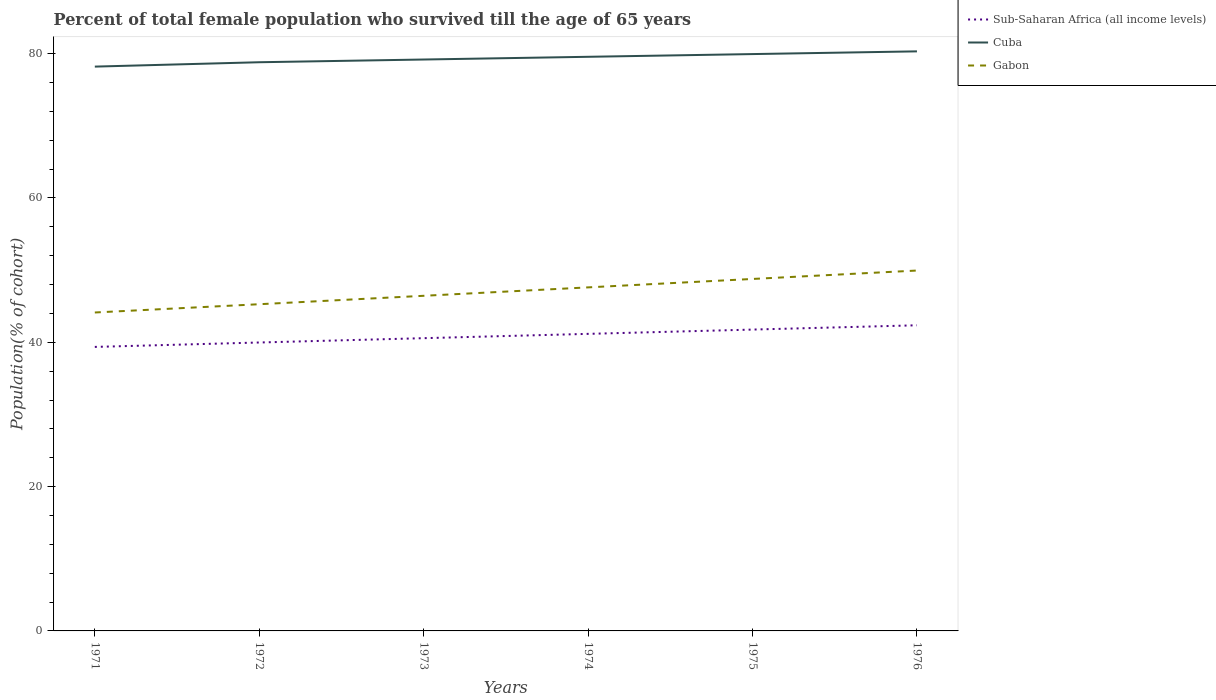How many different coloured lines are there?
Your response must be concise. 3. Does the line corresponding to Gabon intersect with the line corresponding to Cuba?
Give a very brief answer. No. Is the number of lines equal to the number of legend labels?
Provide a succinct answer. Yes. Across all years, what is the maximum percentage of total female population who survived till the age of 65 years in Sub-Saharan Africa (all income levels)?
Keep it short and to the point. 39.36. What is the total percentage of total female population who survived till the age of 65 years in Cuba in the graph?
Your answer should be very brief. -1.51. What is the difference between the highest and the second highest percentage of total female population who survived till the age of 65 years in Gabon?
Make the answer very short. 5.81. What is the difference between the highest and the lowest percentage of total female population who survived till the age of 65 years in Gabon?
Your answer should be compact. 3. How many lines are there?
Your response must be concise. 3. How many years are there in the graph?
Provide a short and direct response. 6. Are the values on the major ticks of Y-axis written in scientific E-notation?
Ensure brevity in your answer.  No. Does the graph contain grids?
Your response must be concise. No. Where does the legend appear in the graph?
Your answer should be very brief. Top right. How many legend labels are there?
Offer a terse response. 3. What is the title of the graph?
Keep it short and to the point. Percent of total female population who survived till the age of 65 years. Does "New Caledonia" appear as one of the legend labels in the graph?
Give a very brief answer. No. What is the label or title of the X-axis?
Provide a short and direct response. Years. What is the label or title of the Y-axis?
Keep it short and to the point. Population(% of cohort). What is the Population(% of cohort) of Sub-Saharan Africa (all income levels) in 1971?
Give a very brief answer. 39.36. What is the Population(% of cohort) in Cuba in 1971?
Make the answer very short. 78.2. What is the Population(% of cohort) of Gabon in 1971?
Offer a very short reply. 44.13. What is the Population(% of cohort) of Sub-Saharan Africa (all income levels) in 1972?
Your answer should be very brief. 39.97. What is the Population(% of cohort) in Cuba in 1972?
Offer a very short reply. 78.81. What is the Population(% of cohort) of Gabon in 1972?
Your response must be concise. 45.27. What is the Population(% of cohort) of Sub-Saharan Africa (all income levels) in 1973?
Keep it short and to the point. 40.57. What is the Population(% of cohort) in Cuba in 1973?
Make the answer very short. 79.18. What is the Population(% of cohort) of Gabon in 1973?
Offer a very short reply. 46.44. What is the Population(% of cohort) in Sub-Saharan Africa (all income levels) in 1974?
Your answer should be compact. 41.16. What is the Population(% of cohort) of Cuba in 1974?
Your response must be concise. 79.56. What is the Population(% of cohort) in Gabon in 1974?
Provide a short and direct response. 47.61. What is the Population(% of cohort) of Sub-Saharan Africa (all income levels) in 1975?
Offer a terse response. 41.76. What is the Population(% of cohort) in Cuba in 1975?
Your response must be concise. 79.94. What is the Population(% of cohort) of Gabon in 1975?
Your response must be concise. 48.77. What is the Population(% of cohort) of Sub-Saharan Africa (all income levels) in 1976?
Give a very brief answer. 42.35. What is the Population(% of cohort) of Cuba in 1976?
Make the answer very short. 80.31. What is the Population(% of cohort) of Gabon in 1976?
Offer a terse response. 49.94. Across all years, what is the maximum Population(% of cohort) in Sub-Saharan Africa (all income levels)?
Ensure brevity in your answer.  42.35. Across all years, what is the maximum Population(% of cohort) in Cuba?
Your answer should be compact. 80.31. Across all years, what is the maximum Population(% of cohort) in Gabon?
Provide a succinct answer. 49.94. Across all years, what is the minimum Population(% of cohort) of Sub-Saharan Africa (all income levels)?
Give a very brief answer. 39.36. Across all years, what is the minimum Population(% of cohort) of Cuba?
Ensure brevity in your answer.  78.2. Across all years, what is the minimum Population(% of cohort) in Gabon?
Offer a terse response. 44.13. What is the total Population(% of cohort) of Sub-Saharan Africa (all income levels) in the graph?
Your response must be concise. 245.17. What is the total Population(% of cohort) of Cuba in the graph?
Ensure brevity in your answer.  476. What is the total Population(% of cohort) of Gabon in the graph?
Make the answer very short. 282.16. What is the difference between the Population(% of cohort) of Sub-Saharan Africa (all income levels) in 1971 and that in 1972?
Your answer should be very brief. -0.61. What is the difference between the Population(% of cohort) of Cuba in 1971 and that in 1972?
Provide a short and direct response. -0.61. What is the difference between the Population(% of cohort) in Gabon in 1971 and that in 1972?
Offer a very short reply. -1.15. What is the difference between the Population(% of cohort) in Sub-Saharan Africa (all income levels) in 1971 and that in 1973?
Your response must be concise. -1.21. What is the difference between the Population(% of cohort) of Cuba in 1971 and that in 1973?
Your answer should be compact. -0.98. What is the difference between the Population(% of cohort) in Gabon in 1971 and that in 1973?
Your answer should be compact. -2.31. What is the difference between the Population(% of cohort) in Sub-Saharan Africa (all income levels) in 1971 and that in 1974?
Your answer should be compact. -1.81. What is the difference between the Population(% of cohort) of Cuba in 1971 and that in 1974?
Your response must be concise. -1.36. What is the difference between the Population(% of cohort) of Gabon in 1971 and that in 1974?
Make the answer very short. -3.48. What is the difference between the Population(% of cohort) of Sub-Saharan Africa (all income levels) in 1971 and that in 1975?
Provide a short and direct response. -2.4. What is the difference between the Population(% of cohort) of Cuba in 1971 and that in 1975?
Keep it short and to the point. -1.74. What is the difference between the Population(% of cohort) in Gabon in 1971 and that in 1975?
Keep it short and to the point. -4.65. What is the difference between the Population(% of cohort) in Sub-Saharan Africa (all income levels) in 1971 and that in 1976?
Offer a terse response. -3. What is the difference between the Population(% of cohort) of Cuba in 1971 and that in 1976?
Provide a succinct answer. -2.11. What is the difference between the Population(% of cohort) of Gabon in 1971 and that in 1976?
Keep it short and to the point. -5.81. What is the difference between the Population(% of cohort) of Sub-Saharan Africa (all income levels) in 1972 and that in 1973?
Provide a short and direct response. -0.6. What is the difference between the Population(% of cohort) in Cuba in 1972 and that in 1973?
Your answer should be very brief. -0.38. What is the difference between the Population(% of cohort) in Gabon in 1972 and that in 1973?
Your response must be concise. -1.17. What is the difference between the Population(% of cohort) in Sub-Saharan Africa (all income levels) in 1972 and that in 1974?
Your answer should be compact. -1.2. What is the difference between the Population(% of cohort) of Cuba in 1972 and that in 1974?
Make the answer very short. -0.75. What is the difference between the Population(% of cohort) in Gabon in 1972 and that in 1974?
Make the answer very short. -2.33. What is the difference between the Population(% of cohort) in Sub-Saharan Africa (all income levels) in 1972 and that in 1975?
Your answer should be compact. -1.79. What is the difference between the Population(% of cohort) in Cuba in 1972 and that in 1975?
Offer a very short reply. -1.13. What is the difference between the Population(% of cohort) in Gabon in 1972 and that in 1975?
Keep it short and to the point. -3.5. What is the difference between the Population(% of cohort) in Sub-Saharan Africa (all income levels) in 1972 and that in 1976?
Provide a short and direct response. -2.39. What is the difference between the Population(% of cohort) of Cuba in 1972 and that in 1976?
Make the answer very short. -1.51. What is the difference between the Population(% of cohort) of Gabon in 1972 and that in 1976?
Your answer should be compact. -4.67. What is the difference between the Population(% of cohort) of Sub-Saharan Africa (all income levels) in 1973 and that in 1974?
Ensure brevity in your answer.  -0.6. What is the difference between the Population(% of cohort) in Cuba in 1973 and that in 1974?
Offer a very short reply. -0.38. What is the difference between the Population(% of cohort) in Gabon in 1973 and that in 1974?
Provide a short and direct response. -1.17. What is the difference between the Population(% of cohort) of Sub-Saharan Africa (all income levels) in 1973 and that in 1975?
Your response must be concise. -1.19. What is the difference between the Population(% of cohort) of Cuba in 1973 and that in 1975?
Your answer should be compact. -0.75. What is the difference between the Population(% of cohort) of Gabon in 1973 and that in 1975?
Your answer should be very brief. -2.33. What is the difference between the Population(% of cohort) in Sub-Saharan Africa (all income levels) in 1973 and that in 1976?
Provide a short and direct response. -1.79. What is the difference between the Population(% of cohort) in Cuba in 1973 and that in 1976?
Your answer should be compact. -1.13. What is the difference between the Population(% of cohort) of Gabon in 1973 and that in 1976?
Provide a succinct answer. -3.5. What is the difference between the Population(% of cohort) in Sub-Saharan Africa (all income levels) in 1974 and that in 1975?
Give a very brief answer. -0.59. What is the difference between the Population(% of cohort) in Cuba in 1974 and that in 1975?
Offer a very short reply. -0.38. What is the difference between the Population(% of cohort) in Gabon in 1974 and that in 1975?
Your answer should be compact. -1.17. What is the difference between the Population(% of cohort) in Sub-Saharan Africa (all income levels) in 1974 and that in 1976?
Offer a terse response. -1.19. What is the difference between the Population(% of cohort) in Cuba in 1974 and that in 1976?
Your answer should be very brief. -0.75. What is the difference between the Population(% of cohort) in Gabon in 1974 and that in 1976?
Provide a succinct answer. -2.33. What is the difference between the Population(% of cohort) in Sub-Saharan Africa (all income levels) in 1975 and that in 1976?
Your answer should be very brief. -0.6. What is the difference between the Population(% of cohort) in Cuba in 1975 and that in 1976?
Ensure brevity in your answer.  -0.38. What is the difference between the Population(% of cohort) in Gabon in 1975 and that in 1976?
Give a very brief answer. -1.17. What is the difference between the Population(% of cohort) of Sub-Saharan Africa (all income levels) in 1971 and the Population(% of cohort) of Cuba in 1972?
Provide a succinct answer. -39.45. What is the difference between the Population(% of cohort) of Sub-Saharan Africa (all income levels) in 1971 and the Population(% of cohort) of Gabon in 1972?
Ensure brevity in your answer.  -5.92. What is the difference between the Population(% of cohort) of Cuba in 1971 and the Population(% of cohort) of Gabon in 1972?
Your answer should be compact. 32.93. What is the difference between the Population(% of cohort) in Sub-Saharan Africa (all income levels) in 1971 and the Population(% of cohort) in Cuba in 1973?
Provide a short and direct response. -39.83. What is the difference between the Population(% of cohort) of Sub-Saharan Africa (all income levels) in 1971 and the Population(% of cohort) of Gabon in 1973?
Your response must be concise. -7.08. What is the difference between the Population(% of cohort) in Cuba in 1971 and the Population(% of cohort) in Gabon in 1973?
Your answer should be compact. 31.76. What is the difference between the Population(% of cohort) of Sub-Saharan Africa (all income levels) in 1971 and the Population(% of cohort) of Cuba in 1974?
Offer a very short reply. -40.2. What is the difference between the Population(% of cohort) of Sub-Saharan Africa (all income levels) in 1971 and the Population(% of cohort) of Gabon in 1974?
Provide a succinct answer. -8.25. What is the difference between the Population(% of cohort) of Cuba in 1971 and the Population(% of cohort) of Gabon in 1974?
Provide a short and direct response. 30.59. What is the difference between the Population(% of cohort) of Sub-Saharan Africa (all income levels) in 1971 and the Population(% of cohort) of Cuba in 1975?
Offer a very short reply. -40.58. What is the difference between the Population(% of cohort) of Sub-Saharan Africa (all income levels) in 1971 and the Population(% of cohort) of Gabon in 1975?
Make the answer very short. -9.42. What is the difference between the Population(% of cohort) of Cuba in 1971 and the Population(% of cohort) of Gabon in 1975?
Offer a very short reply. 29.43. What is the difference between the Population(% of cohort) of Sub-Saharan Africa (all income levels) in 1971 and the Population(% of cohort) of Cuba in 1976?
Keep it short and to the point. -40.96. What is the difference between the Population(% of cohort) of Sub-Saharan Africa (all income levels) in 1971 and the Population(% of cohort) of Gabon in 1976?
Your answer should be very brief. -10.58. What is the difference between the Population(% of cohort) in Cuba in 1971 and the Population(% of cohort) in Gabon in 1976?
Ensure brevity in your answer.  28.26. What is the difference between the Population(% of cohort) of Sub-Saharan Africa (all income levels) in 1972 and the Population(% of cohort) of Cuba in 1973?
Give a very brief answer. -39.21. What is the difference between the Population(% of cohort) of Sub-Saharan Africa (all income levels) in 1972 and the Population(% of cohort) of Gabon in 1973?
Provide a succinct answer. -6.47. What is the difference between the Population(% of cohort) in Cuba in 1972 and the Population(% of cohort) in Gabon in 1973?
Your answer should be compact. 32.37. What is the difference between the Population(% of cohort) in Sub-Saharan Africa (all income levels) in 1972 and the Population(% of cohort) in Cuba in 1974?
Provide a succinct answer. -39.59. What is the difference between the Population(% of cohort) in Sub-Saharan Africa (all income levels) in 1972 and the Population(% of cohort) in Gabon in 1974?
Keep it short and to the point. -7.64. What is the difference between the Population(% of cohort) in Cuba in 1972 and the Population(% of cohort) in Gabon in 1974?
Keep it short and to the point. 31.2. What is the difference between the Population(% of cohort) in Sub-Saharan Africa (all income levels) in 1972 and the Population(% of cohort) in Cuba in 1975?
Offer a very short reply. -39.97. What is the difference between the Population(% of cohort) in Sub-Saharan Africa (all income levels) in 1972 and the Population(% of cohort) in Gabon in 1975?
Provide a succinct answer. -8.81. What is the difference between the Population(% of cohort) in Cuba in 1972 and the Population(% of cohort) in Gabon in 1975?
Your answer should be compact. 30.03. What is the difference between the Population(% of cohort) in Sub-Saharan Africa (all income levels) in 1972 and the Population(% of cohort) in Cuba in 1976?
Ensure brevity in your answer.  -40.35. What is the difference between the Population(% of cohort) of Sub-Saharan Africa (all income levels) in 1972 and the Population(% of cohort) of Gabon in 1976?
Your answer should be very brief. -9.97. What is the difference between the Population(% of cohort) in Cuba in 1972 and the Population(% of cohort) in Gabon in 1976?
Keep it short and to the point. 28.87. What is the difference between the Population(% of cohort) in Sub-Saharan Africa (all income levels) in 1973 and the Population(% of cohort) in Cuba in 1974?
Make the answer very short. -38.99. What is the difference between the Population(% of cohort) of Sub-Saharan Africa (all income levels) in 1973 and the Population(% of cohort) of Gabon in 1974?
Give a very brief answer. -7.04. What is the difference between the Population(% of cohort) in Cuba in 1973 and the Population(% of cohort) in Gabon in 1974?
Your response must be concise. 31.58. What is the difference between the Population(% of cohort) in Sub-Saharan Africa (all income levels) in 1973 and the Population(% of cohort) in Cuba in 1975?
Ensure brevity in your answer.  -39.37. What is the difference between the Population(% of cohort) in Sub-Saharan Africa (all income levels) in 1973 and the Population(% of cohort) in Gabon in 1975?
Your answer should be compact. -8.21. What is the difference between the Population(% of cohort) of Cuba in 1973 and the Population(% of cohort) of Gabon in 1975?
Ensure brevity in your answer.  30.41. What is the difference between the Population(% of cohort) of Sub-Saharan Africa (all income levels) in 1973 and the Population(% of cohort) of Cuba in 1976?
Your answer should be compact. -39.75. What is the difference between the Population(% of cohort) in Sub-Saharan Africa (all income levels) in 1973 and the Population(% of cohort) in Gabon in 1976?
Your answer should be compact. -9.37. What is the difference between the Population(% of cohort) in Cuba in 1973 and the Population(% of cohort) in Gabon in 1976?
Your answer should be very brief. 29.24. What is the difference between the Population(% of cohort) of Sub-Saharan Africa (all income levels) in 1974 and the Population(% of cohort) of Cuba in 1975?
Your answer should be very brief. -38.77. What is the difference between the Population(% of cohort) in Sub-Saharan Africa (all income levels) in 1974 and the Population(% of cohort) in Gabon in 1975?
Your answer should be very brief. -7.61. What is the difference between the Population(% of cohort) in Cuba in 1974 and the Population(% of cohort) in Gabon in 1975?
Give a very brief answer. 30.79. What is the difference between the Population(% of cohort) of Sub-Saharan Africa (all income levels) in 1974 and the Population(% of cohort) of Cuba in 1976?
Keep it short and to the point. -39.15. What is the difference between the Population(% of cohort) in Sub-Saharan Africa (all income levels) in 1974 and the Population(% of cohort) in Gabon in 1976?
Provide a short and direct response. -8.78. What is the difference between the Population(% of cohort) in Cuba in 1974 and the Population(% of cohort) in Gabon in 1976?
Your answer should be very brief. 29.62. What is the difference between the Population(% of cohort) in Sub-Saharan Africa (all income levels) in 1975 and the Population(% of cohort) in Cuba in 1976?
Keep it short and to the point. -38.56. What is the difference between the Population(% of cohort) in Sub-Saharan Africa (all income levels) in 1975 and the Population(% of cohort) in Gabon in 1976?
Offer a terse response. -8.18. What is the difference between the Population(% of cohort) of Cuba in 1975 and the Population(% of cohort) of Gabon in 1976?
Provide a short and direct response. 30. What is the average Population(% of cohort) in Sub-Saharan Africa (all income levels) per year?
Provide a short and direct response. 40.86. What is the average Population(% of cohort) in Cuba per year?
Provide a short and direct response. 79.33. What is the average Population(% of cohort) of Gabon per year?
Provide a short and direct response. 47.03. In the year 1971, what is the difference between the Population(% of cohort) in Sub-Saharan Africa (all income levels) and Population(% of cohort) in Cuba?
Offer a terse response. -38.84. In the year 1971, what is the difference between the Population(% of cohort) in Sub-Saharan Africa (all income levels) and Population(% of cohort) in Gabon?
Your answer should be compact. -4.77. In the year 1971, what is the difference between the Population(% of cohort) of Cuba and Population(% of cohort) of Gabon?
Give a very brief answer. 34.07. In the year 1972, what is the difference between the Population(% of cohort) of Sub-Saharan Africa (all income levels) and Population(% of cohort) of Cuba?
Your response must be concise. -38.84. In the year 1972, what is the difference between the Population(% of cohort) of Sub-Saharan Africa (all income levels) and Population(% of cohort) of Gabon?
Offer a very short reply. -5.3. In the year 1972, what is the difference between the Population(% of cohort) of Cuba and Population(% of cohort) of Gabon?
Provide a short and direct response. 33.53. In the year 1973, what is the difference between the Population(% of cohort) in Sub-Saharan Africa (all income levels) and Population(% of cohort) in Cuba?
Provide a short and direct response. -38.61. In the year 1973, what is the difference between the Population(% of cohort) of Sub-Saharan Africa (all income levels) and Population(% of cohort) of Gabon?
Provide a succinct answer. -5.87. In the year 1973, what is the difference between the Population(% of cohort) of Cuba and Population(% of cohort) of Gabon?
Your answer should be very brief. 32.74. In the year 1974, what is the difference between the Population(% of cohort) of Sub-Saharan Africa (all income levels) and Population(% of cohort) of Cuba?
Offer a very short reply. -38.4. In the year 1974, what is the difference between the Population(% of cohort) of Sub-Saharan Africa (all income levels) and Population(% of cohort) of Gabon?
Offer a very short reply. -6.44. In the year 1974, what is the difference between the Population(% of cohort) in Cuba and Population(% of cohort) in Gabon?
Make the answer very short. 31.95. In the year 1975, what is the difference between the Population(% of cohort) of Sub-Saharan Africa (all income levels) and Population(% of cohort) of Cuba?
Ensure brevity in your answer.  -38.18. In the year 1975, what is the difference between the Population(% of cohort) of Sub-Saharan Africa (all income levels) and Population(% of cohort) of Gabon?
Keep it short and to the point. -7.02. In the year 1975, what is the difference between the Population(% of cohort) of Cuba and Population(% of cohort) of Gabon?
Give a very brief answer. 31.16. In the year 1976, what is the difference between the Population(% of cohort) of Sub-Saharan Africa (all income levels) and Population(% of cohort) of Cuba?
Keep it short and to the point. -37.96. In the year 1976, what is the difference between the Population(% of cohort) in Sub-Saharan Africa (all income levels) and Population(% of cohort) in Gabon?
Provide a short and direct response. -7.59. In the year 1976, what is the difference between the Population(% of cohort) of Cuba and Population(% of cohort) of Gabon?
Ensure brevity in your answer.  30.37. What is the ratio of the Population(% of cohort) in Sub-Saharan Africa (all income levels) in 1971 to that in 1972?
Keep it short and to the point. 0.98. What is the ratio of the Population(% of cohort) in Cuba in 1971 to that in 1972?
Your answer should be very brief. 0.99. What is the ratio of the Population(% of cohort) in Gabon in 1971 to that in 1972?
Your answer should be compact. 0.97. What is the ratio of the Population(% of cohort) in Sub-Saharan Africa (all income levels) in 1971 to that in 1973?
Make the answer very short. 0.97. What is the ratio of the Population(% of cohort) in Cuba in 1971 to that in 1973?
Provide a short and direct response. 0.99. What is the ratio of the Population(% of cohort) of Gabon in 1971 to that in 1973?
Provide a short and direct response. 0.95. What is the ratio of the Population(% of cohort) of Sub-Saharan Africa (all income levels) in 1971 to that in 1974?
Provide a short and direct response. 0.96. What is the ratio of the Population(% of cohort) in Cuba in 1971 to that in 1974?
Provide a succinct answer. 0.98. What is the ratio of the Population(% of cohort) of Gabon in 1971 to that in 1974?
Make the answer very short. 0.93. What is the ratio of the Population(% of cohort) of Sub-Saharan Africa (all income levels) in 1971 to that in 1975?
Give a very brief answer. 0.94. What is the ratio of the Population(% of cohort) of Cuba in 1971 to that in 1975?
Give a very brief answer. 0.98. What is the ratio of the Population(% of cohort) in Gabon in 1971 to that in 1975?
Provide a succinct answer. 0.9. What is the ratio of the Population(% of cohort) of Sub-Saharan Africa (all income levels) in 1971 to that in 1976?
Your answer should be compact. 0.93. What is the ratio of the Population(% of cohort) in Cuba in 1971 to that in 1976?
Offer a terse response. 0.97. What is the ratio of the Population(% of cohort) in Gabon in 1971 to that in 1976?
Offer a terse response. 0.88. What is the ratio of the Population(% of cohort) of Sub-Saharan Africa (all income levels) in 1972 to that in 1973?
Give a very brief answer. 0.99. What is the ratio of the Population(% of cohort) in Gabon in 1972 to that in 1973?
Your answer should be compact. 0.97. What is the ratio of the Population(% of cohort) in Sub-Saharan Africa (all income levels) in 1972 to that in 1974?
Offer a very short reply. 0.97. What is the ratio of the Population(% of cohort) of Cuba in 1972 to that in 1974?
Give a very brief answer. 0.99. What is the ratio of the Population(% of cohort) of Gabon in 1972 to that in 1974?
Give a very brief answer. 0.95. What is the ratio of the Population(% of cohort) of Sub-Saharan Africa (all income levels) in 1972 to that in 1975?
Your answer should be compact. 0.96. What is the ratio of the Population(% of cohort) of Cuba in 1972 to that in 1975?
Offer a terse response. 0.99. What is the ratio of the Population(% of cohort) of Gabon in 1972 to that in 1975?
Your response must be concise. 0.93. What is the ratio of the Population(% of cohort) in Sub-Saharan Africa (all income levels) in 1972 to that in 1976?
Your answer should be very brief. 0.94. What is the ratio of the Population(% of cohort) of Cuba in 1972 to that in 1976?
Provide a succinct answer. 0.98. What is the ratio of the Population(% of cohort) of Gabon in 1972 to that in 1976?
Make the answer very short. 0.91. What is the ratio of the Population(% of cohort) of Sub-Saharan Africa (all income levels) in 1973 to that in 1974?
Ensure brevity in your answer.  0.99. What is the ratio of the Population(% of cohort) of Gabon in 1973 to that in 1974?
Your response must be concise. 0.98. What is the ratio of the Population(% of cohort) in Sub-Saharan Africa (all income levels) in 1973 to that in 1975?
Give a very brief answer. 0.97. What is the ratio of the Population(% of cohort) in Cuba in 1973 to that in 1975?
Make the answer very short. 0.99. What is the ratio of the Population(% of cohort) of Gabon in 1973 to that in 1975?
Ensure brevity in your answer.  0.95. What is the ratio of the Population(% of cohort) of Sub-Saharan Africa (all income levels) in 1973 to that in 1976?
Your answer should be very brief. 0.96. What is the ratio of the Population(% of cohort) of Cuba in 1973 to that in 1976?
Your answer should be compact. 0.99. What is the ratio of the Population(% of cohort) of Gabon in 1973 to that in 1976?
Your answer should be very brief. 0.93. What is the ratio of the Population(% of cohort) in Sub-Saharan Africa (all income levels) in 1974 to that in 1975?
Provide a succinct answer. 0.99. What is the ratio of the Population(% of cohort) of Cuba in 1974 to that in 1975?
Ensure brevity in your answer.  1. What is the ratio of the Population(% of cohort) of Gabon in 1974 to that in 1975?
Ensure brevity in your answer.  0.98. What is the ratio of the Population(% of cohort) in Sub-Saharan Africa (all income levels) in 1974 to that in 1976?
Your answer should be compact. 0.97. What is the ratio of the Population(% of cohort) of Cuba in 1974 to that in 1976?
Your answer should be compact. 0.99. What is the ratio of the Population(% of cohort) of Gabon in 1974 to that in 1976?
Provide a succinct answer. 0.95. What is the ratio of the Population(% of cohort) of Sub-Saharan Africa (all income levels) in 1975 to that in 1976?
Ensure brevity in your answer.  0.99. What is the ratio of the Population(% of cohort) of Cuba in 1975 to that in 1976?
Your answer should be very brief. 1. What is the ratio of the Population(% of cohort) in Gabon in 1975 to that in 1976?
Provide a short and direct response. 0.98. What is the difference between the highest and the second highest Population(% of cohort) in Sub-Saharan Africa (all income levels)?
Your answer should be very brief. 0.6. What is the difference between the highest and the second highest Population(% of cohort) in Cuba?
Make the answer very short. 0.38. What is the difference between the highest and the second highest Population(% of cohort) of Gabon?
Provide a short and direct response. 1.17. What is the difference between the highest and the lowest Population(% of cohort) of Sub-Saharan Africa (all income levels)?
Give a very brief answer. 3. What is the difference between the highest and the lowest Population(% of cohort) of Cuba?
Offer a terse response. 2.11. What is the difference between the highest and the lowest Population(% of cohort) of Gabon?
Give a very brief answer. 5.81. 